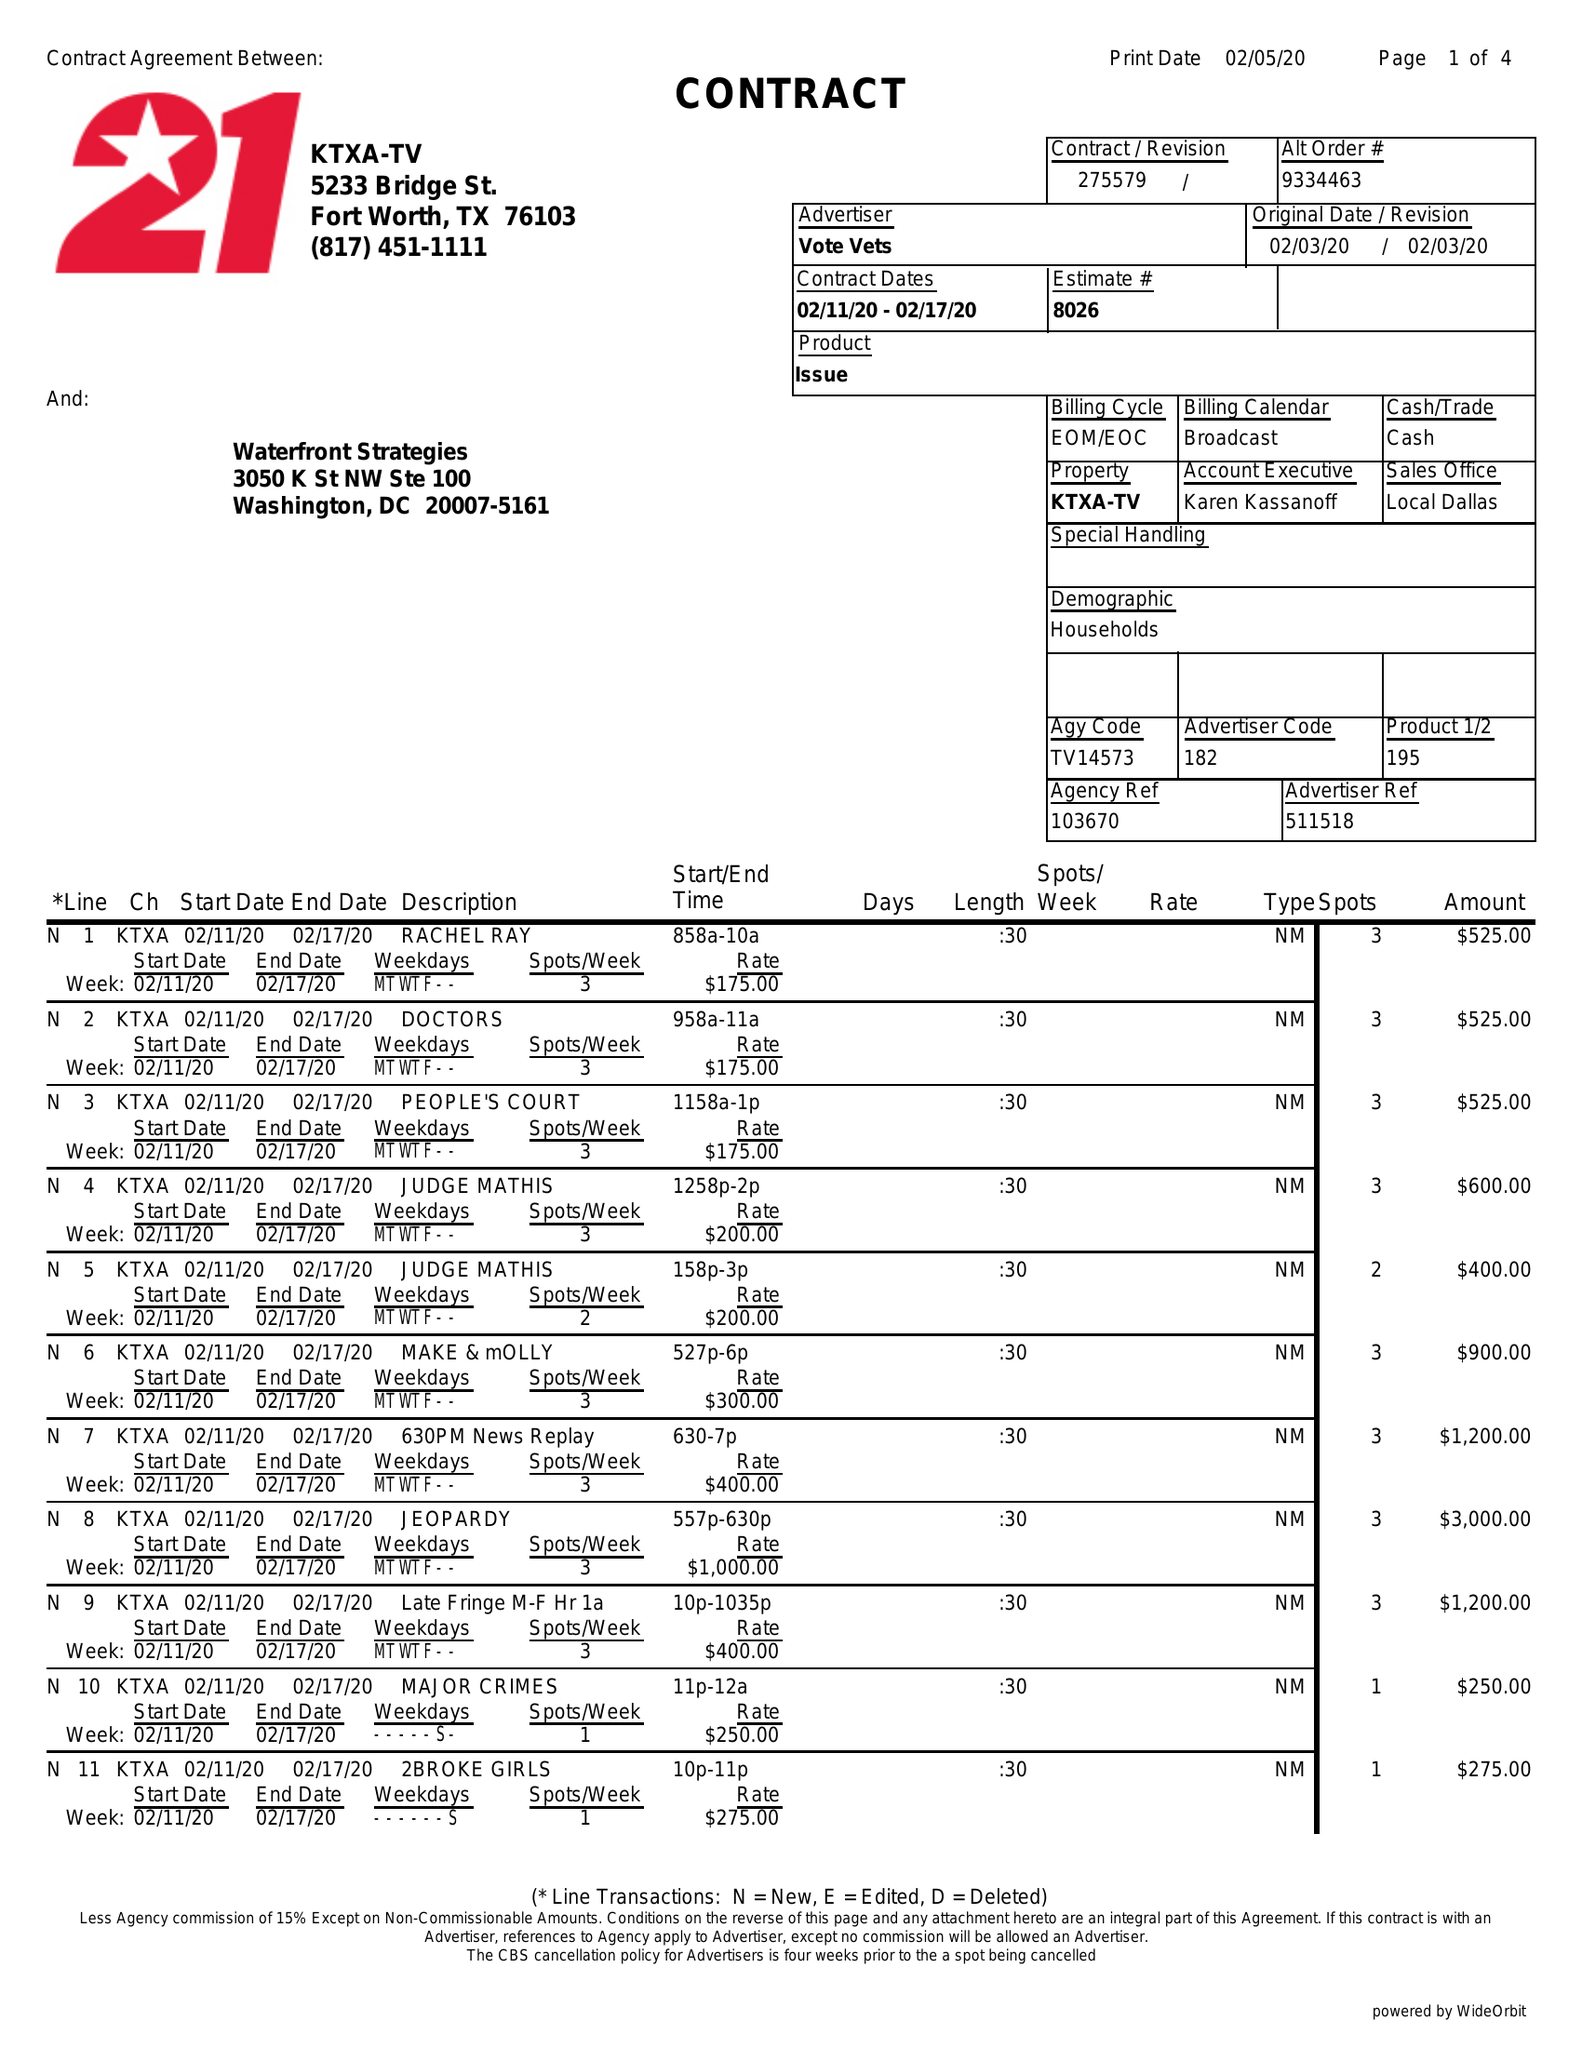What is the value for the flight_to?
Answer the question using a single word or phrase. 02/17/20 